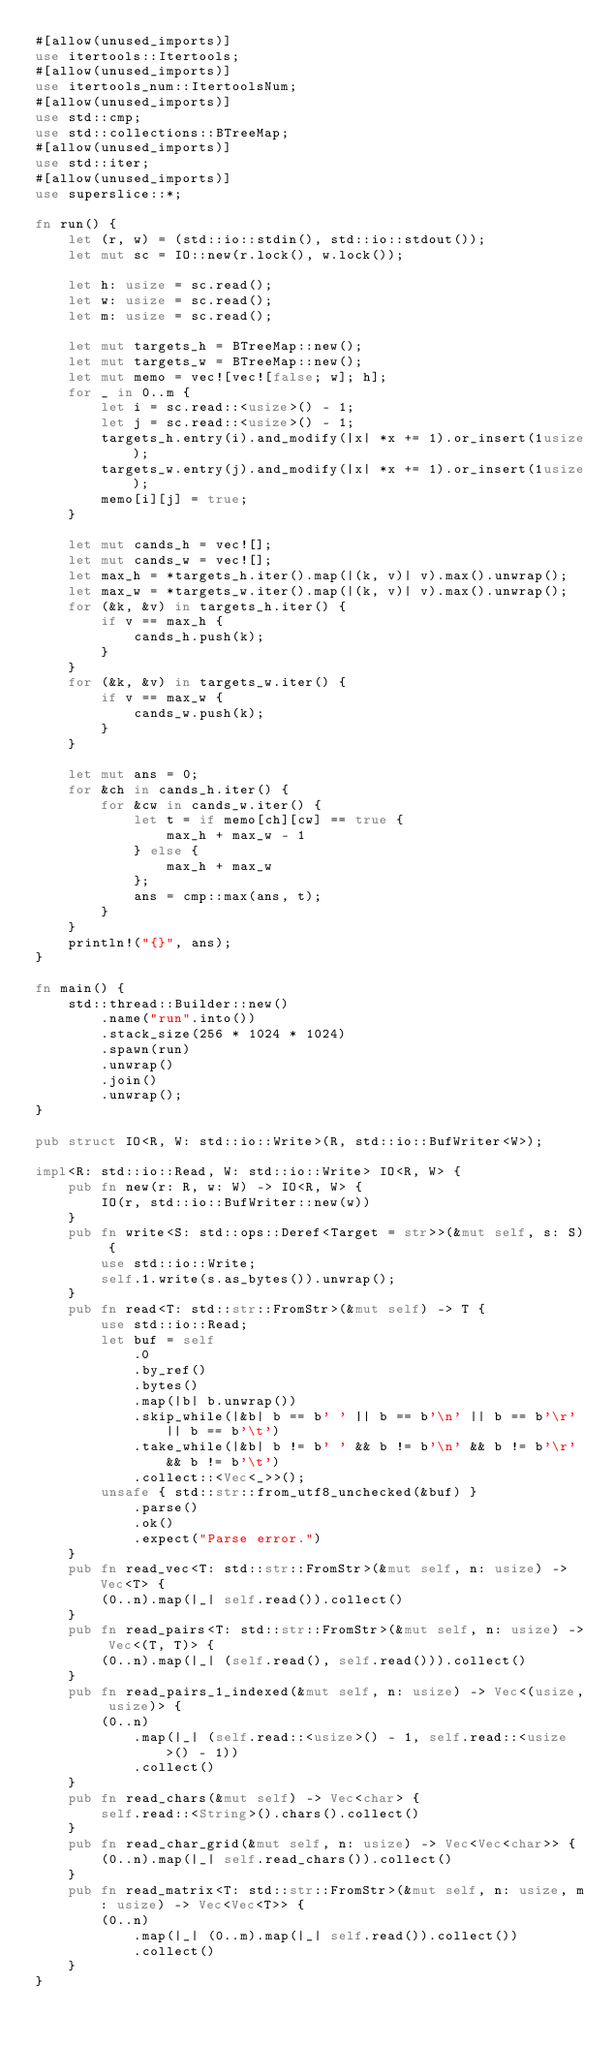<code> <loc_0><loc_0><loc_500><loc_500><_Rust_>#[allow(unused_imports)]
use itertools::Itertools;
#[allow(unused_imports)]
use itertools_num::ItertoolsNum;
#[allow(unused_imports)]
use std::cmp;
use std::collections::BTreeMap;
#[allow(unused_imports)]
use std::iter;
#[allow(unused_imports)]
use superslice::*;

fn run() {
    let (r, w) = (std::io::stdin(), std::io::stdout());
    let mut sc = IO::new(r.lock(), w.lock());

    let h: usize = sc.read();
    let w: usize = sc.read();
    let m: usize = sc.read();

    let mut targets_h = BTreeMap::new();
    let mut targets_w = BTreeMap::new();
    let mut memo = vec![vec![false; w]; h];
    for _ in 0..m {
        let i = sc.read::<usize>() - 1;
        let j = sc.read::<usize>() - 1;
        targets_h.entry(i).and_modify(|x| *x += 1).or_insert(1usize);
        targets_w.entry(j).and_modify(|x| *x += 1).or_insert(1usize);
        memo[i][j] = true;
    }

    let mut cands_h = vec![];
    let mut cands_w = vec![];
    let max_h = *targets_h.iter().map(|(k, v)| v).max().unwrap();
    let max_w = *targets_w.iter().map(|(k, v)| v).max().unwrap();
    for (&k, &v) in targets_h.iter() {
        if v == max_h {
            cands_h.push(k);
        }
    }
    for (&k, &v) in targets_w.iter() {
        if v == max_w {
            cands_w.push(k);
        }
    }

    let mut ans = 0;
    for &ch in cands_h.iter() {
        for &cw in cands_w.iter() {
            let t = if memo[ch][cw] == true {
                max_h + max_w - 1
            } else {
                max_h + max_w
            };
            ans = cmp::max(ans, t);
        }
    }
    println!("{}", ans);
}

fn main() {
    std::thread::Builder::new()
        .name("run".into())
        .stack_size(256 * 1024 * 1024)
        .spawn(run)
        .unwrap()
        .join()
        .unwrap();
}

pub struct IO<R, W: std::io::Write>(R, std::io::BufWriter<W>);

impl<R: std::io::Read, W: std::io::Write> IO<R, W> {
    pub fn new(r: R, w: W) -> IO<R, W> {
        IO(r, std::io::BufWriter::new(w))
    }
    pub fn write<S: std::ops::Deref<Target = str>>(&mut self, s: S) {
        use std::io::Write;
        self.1.write(s.as_bytes()).unwrap();
    }
    pub fn read<T: std::str::FromStr>(&mut self) -> T {
        use std::io::Read;
        let buf = self
            .0
            .by_ref()
            .bytes()
            .map(|b| b.unwrap())
            .skip_while(|&b| b == b' ' || b == b'\n' || b == b'\r' || b == b'\t')
            .take_while(|&b| b != b' ' && b != b'\n' && b != b'\r' && b != b'\t')
            .collect::<Vec<_>>();
        unsafe { std::str::from_utf8_unchecked(&buf) }
            .parse()
            .ok()
            .expect("Parse error.")
    }
    pub fn read_vec<T: std::str::FromStr>(&mut self, n: usize) -> Vec<T> {
        (0..n).map(|_| self.read()).collect()
    }
    pub fn read_pairs<T: std::str::FromStr>(&mut self, n: usize) -> Vec<(T, T)> {
        (0..n).map(|_| (self.read(), self.read())).collect()
    }
    pub fn read_pairs_1_indexed(&mut self, n: usize) -> Vec<(usize, usize)> {
        (0..n)
            .map(|_| (self.read::<usize>() - 1, self.read::<usize>() - 1))
            .collect()
    }
    pub fn read_chars(&mut self) -> Vec<char> {
        self.read::<String>().chars().collect()
    }
    pub fn read_char_grid(&mut self, n: usize) -> Vec<Vec<char>> {
        (0..n).map(|_| self.read_chars()).collect()
    }
    pub fn read_matrix<T: std::str::FromStr>(&mut self, n: usize, m: usize) -> Vec<Vec<T>> {
        (0..n)
            .map(|_| (0..m).map(|_| self.read()).collect())
            .collect()
    }
}
</code> 